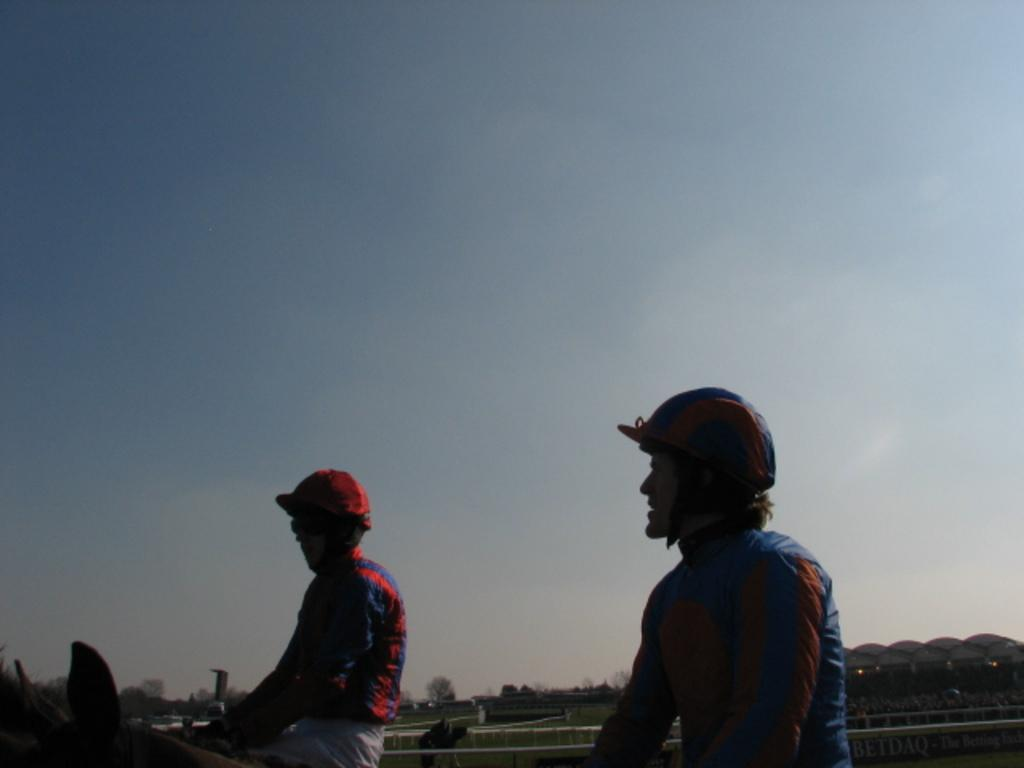How many people are present in the image? There are two people in the image. What animal is present in the image? There is a horse in the image. What type of vegetation can be seen in the background of the image? There are trees and grass in the background of the image. Where is the stadium located in the image? The stadium is on the right side of the image. What is visible in the sky in the image? The sky is visible in the image. What type of wound can be seen on the horse in the image? There is no wound visible on the horse in the image. Can you compare the size of the trees in the background? The question cannot be answered definitively from the provided facts, as it requires a comparison that is not present in the image. 